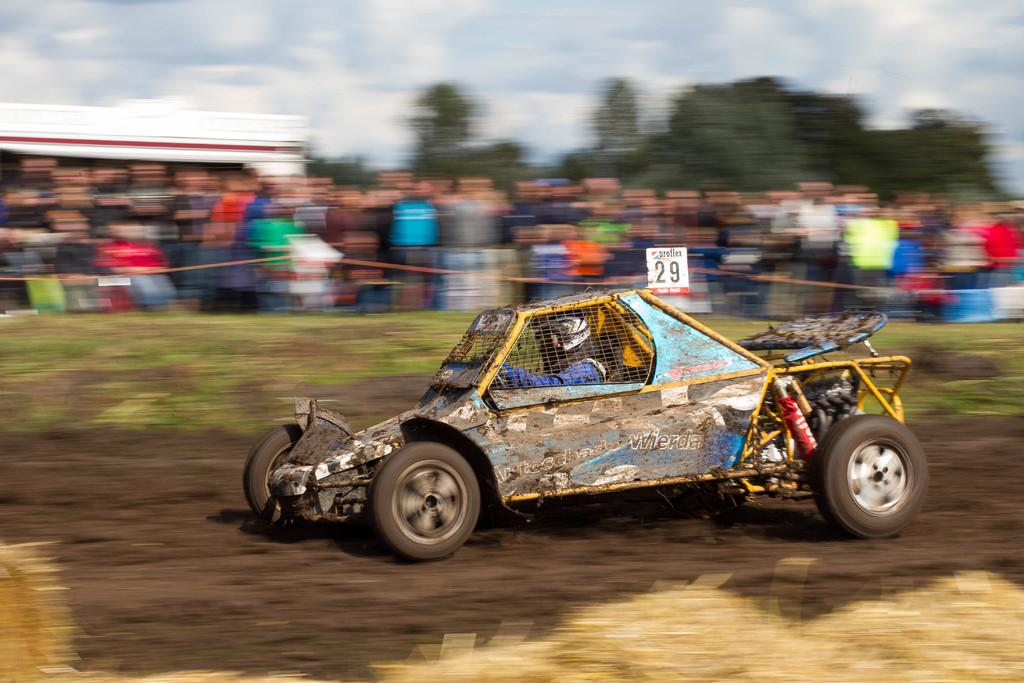What is the person in the image doing? There is a person riding a car in the image. What is the condition of the road in the image? The car is on a mud road. Are there any other people present in the image? Yes, there are people standing beside the car. What type of natural scenery can be seen in the image? Trees are visible in the image. How many pigs can be seen running alongside the car in the image? There are no pigs visible in the image. 